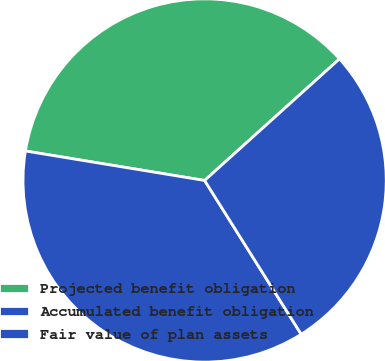<chart> <loc_0><loc_0><loc_500><loc_500><pie_chart><fcel>Projected benefit obligation<fcel>Accumulated benefit obligation<fcel>Fair value of plan assets<nl><fcel>35.73%<fcel>36.52%<fcel>27.75%<nl></chart> 